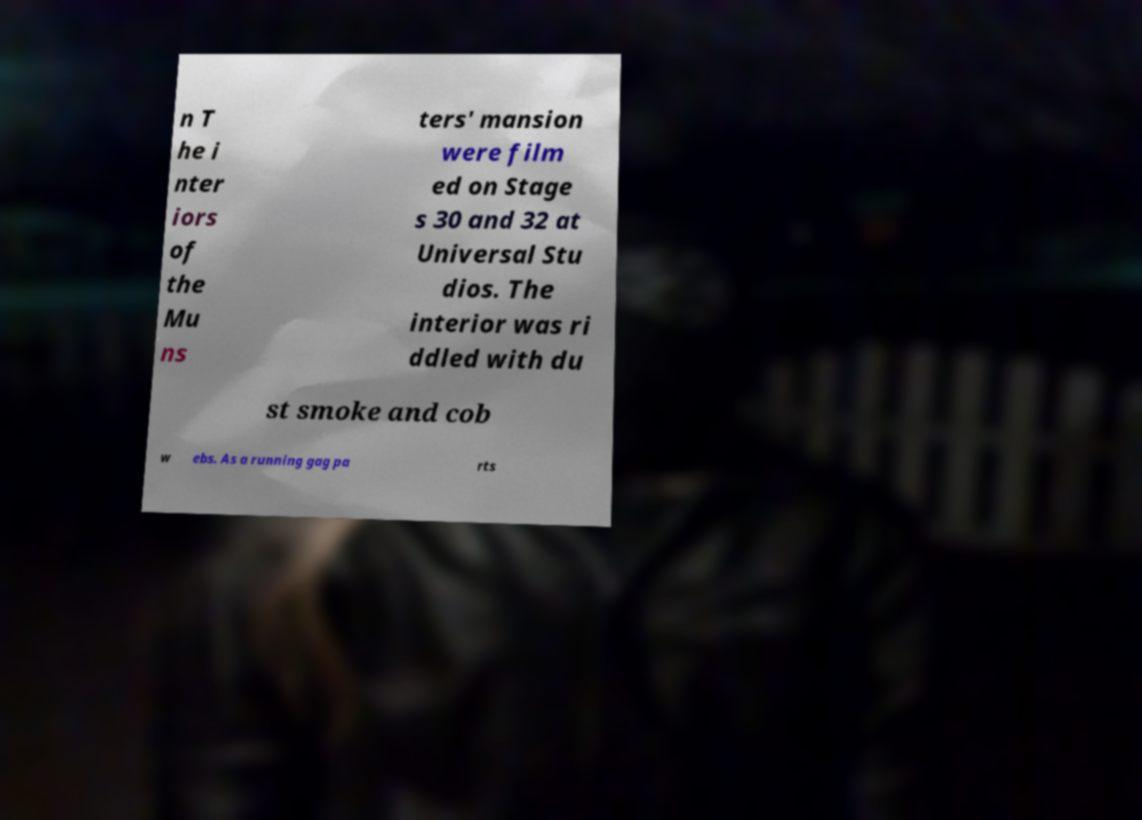Could you assist in decoding the text presented in this image and type it out clearly? n T he i nter iors of the Mu ns ters' mansion were film ed on Stage s 30 and 32 at Universal Stu dios. The interior was ri ddled with du st smoke and cob w ebs. As a running gag pa rts 